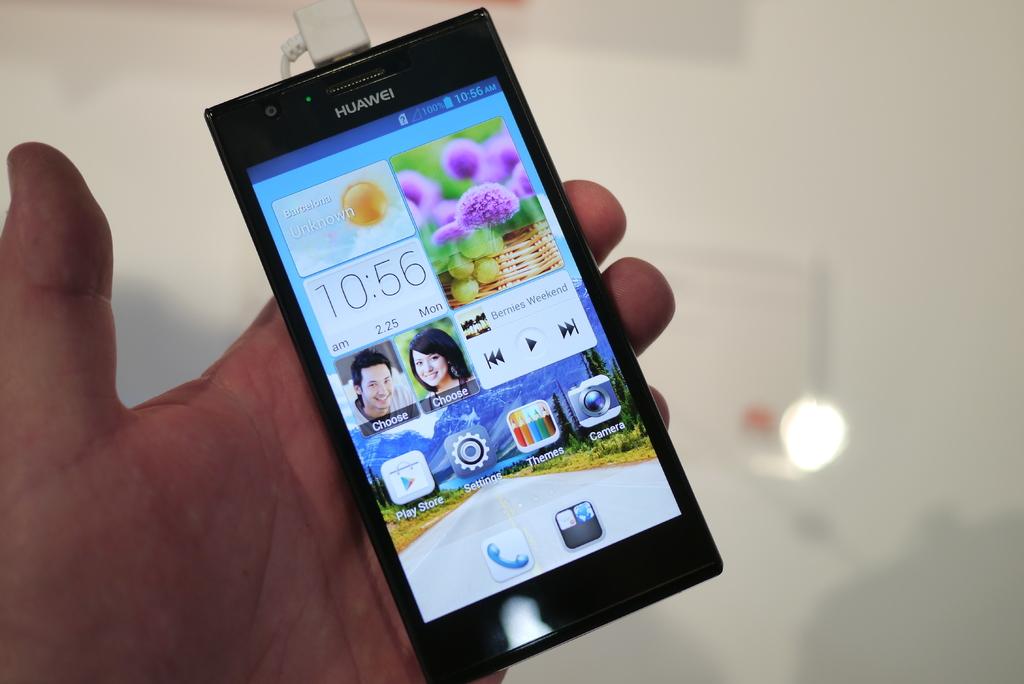What time is being displayed?
Offer a terse response. 10:56. What brand of phone is it?
Offer a very short reply. Huawei. 